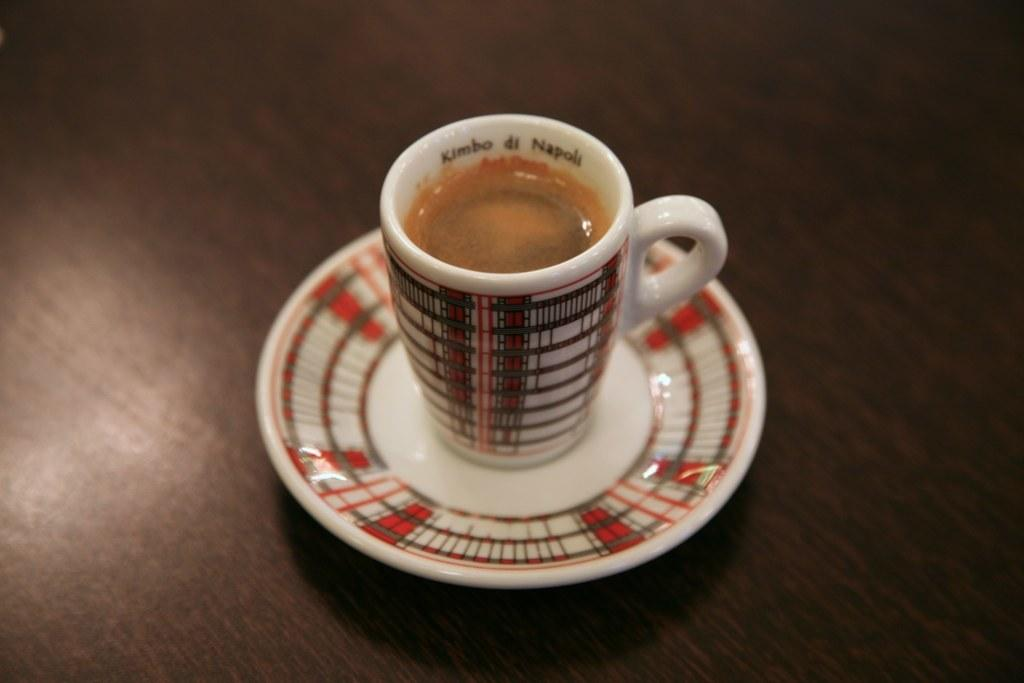What piece of furniture is present in the image? There is a table in the image. What object is placed on the table? There is a cup on the table. What type of skirt is visible on the cup in the image? There is no skirt present in the image, as the cup is an inanimate object and does not wear clothing. 